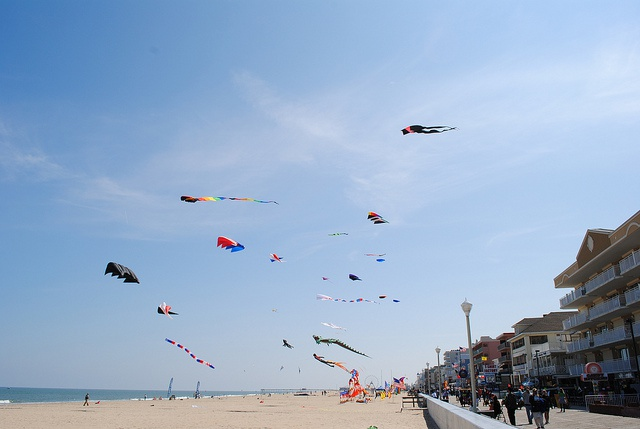Describe the objects in this image and their specific colors. I can see kite in gray, lightblue, lightgray, and darkgray tones, people in gray, black, darkgray, and tan tones, kite in gray, black, lavender, and lightblue tones, kite in gray, black, and blue tones, and kite in gray, darkgray, lightblue, black, and salmon tones in this image. 